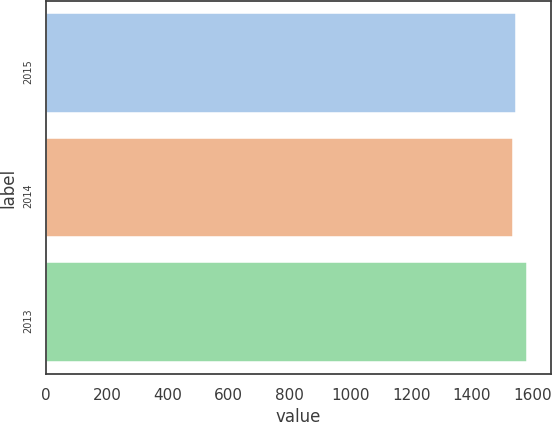<chart> <loc_0><loc_0><loc_500><loc_500><bar_chart><fcel>2015<fcel>2014<fcel>2013<nl><fcel>1545<fcel>1536<fcel>1580<nl></chart> 